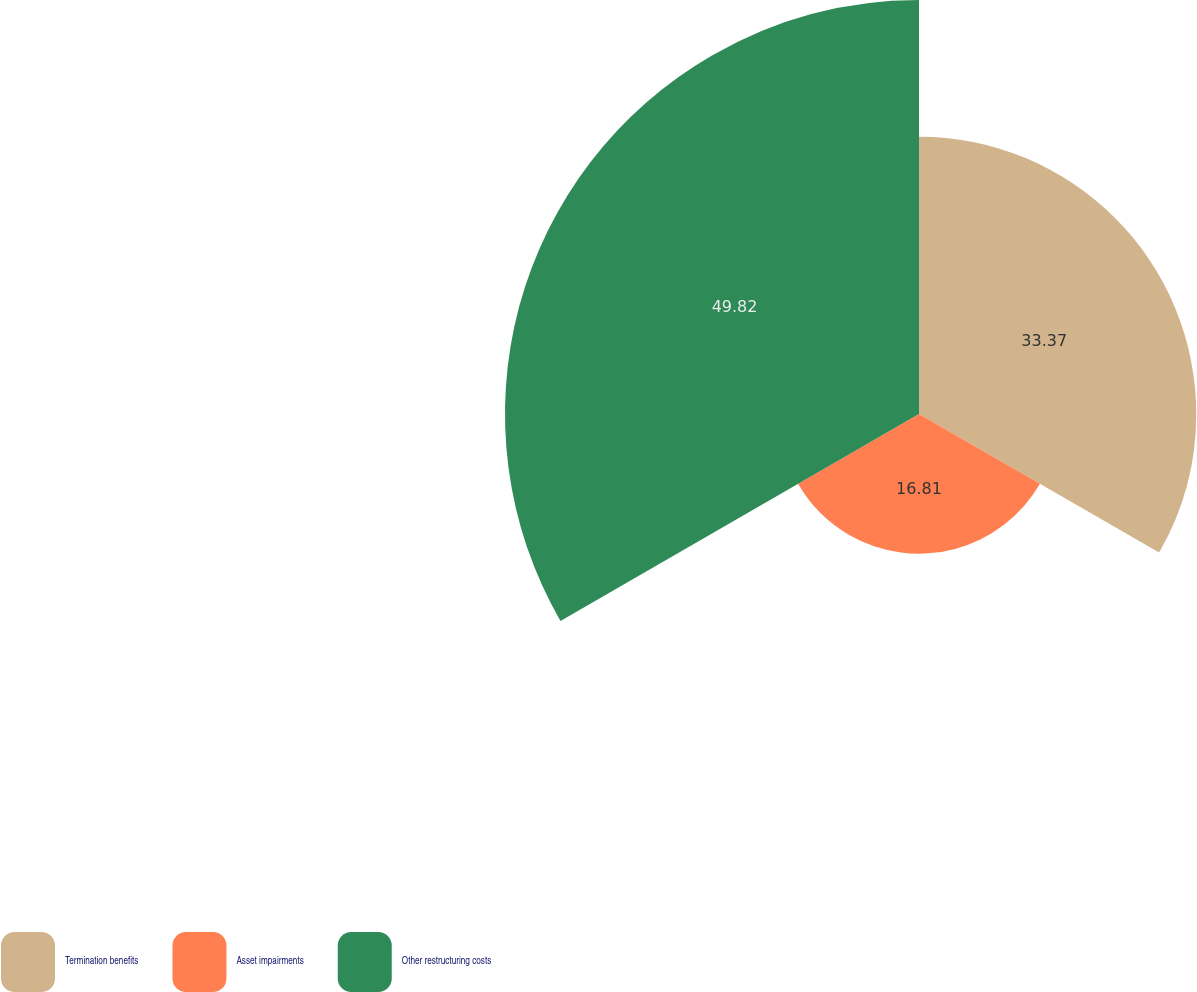Convert chart. <chart><loc_0><loc_0><loc_500><loc_500><pie_chart><fcel>Termination benefits<fcel>Asset impairments<fcel>Other restructuring costs<nl><fcel>33.37%<fcel>16.81%<fcel>49.83%<nl></chart> 